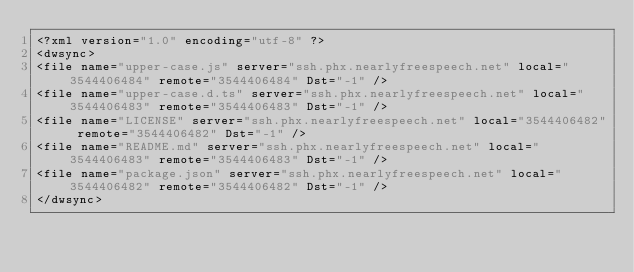<code> <loc_0><loc_0><loc_500><loc_500><_XML_><?xml version="1.0" encoding="utf-8" ?><dwsync><file name="upper-case.js" server="ssh.phx.nearlyfreespeech.net" local="3544406484" remote="3544406484" Dst="-1" /><file name="upper-case.d.ts" server="ssh.phx.nearlyfreespeech.net" local="3544406483" remote="3544406483" Dst="-1" /><file name="LICENSE" server="ssh.phx.nearlyfreespeech.net" local="3544406482" remote="3544406482" Dst="-1" /><file name="README.md" server="ssh.phx.nearlyfreespeech.net" local="3544406483" remote="3544406483" Dst="-1" /><file name="package.json" server="ssh.phx.nearlyfreespeech.net" local="3544406482" remote="3544406482" Dst="-1" /></dwsync></code> 